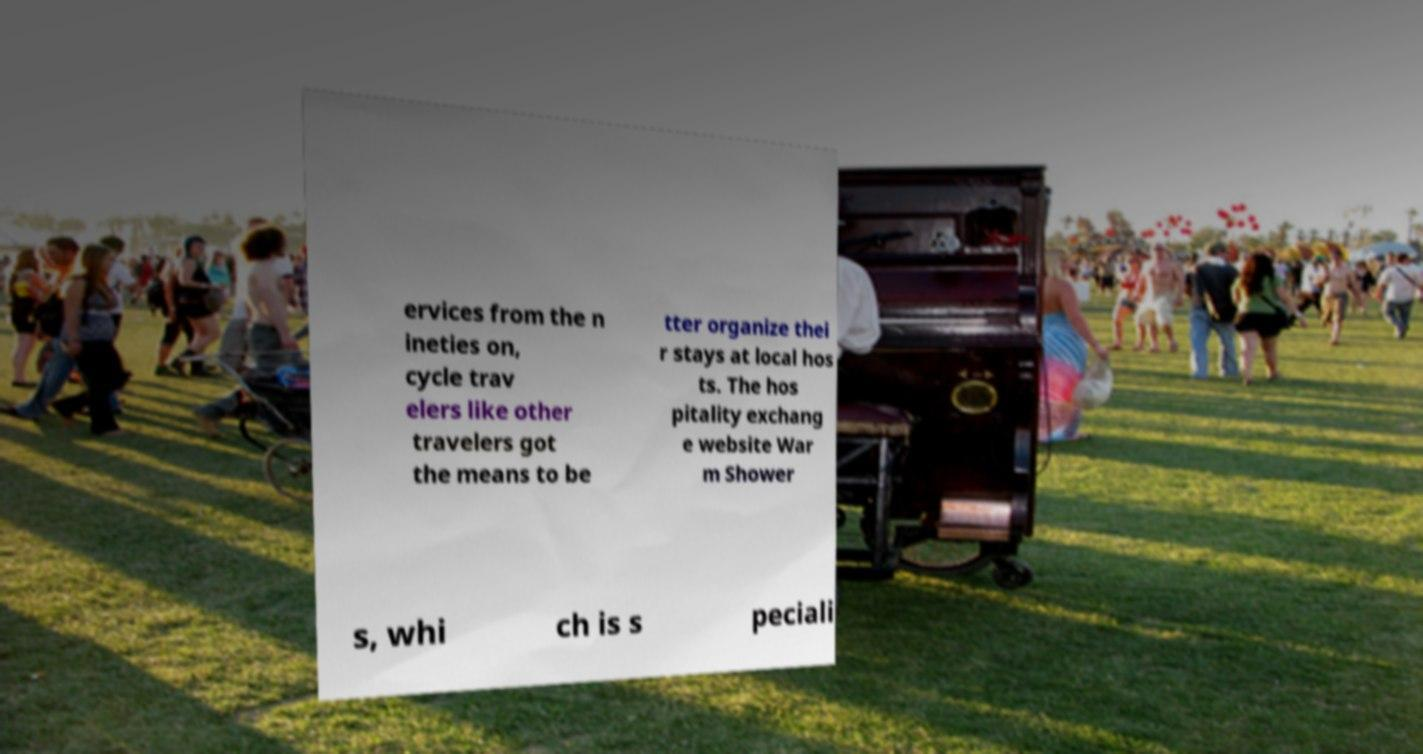Can you accurately transcribe the text from the provided image for me? ervices from the n ineties on, cycle trav elers like other travelers got the means to be tter organize thei r stays at local hos ts. The hos pitality exchang e website War m Shower s, whi ch is s peciali 